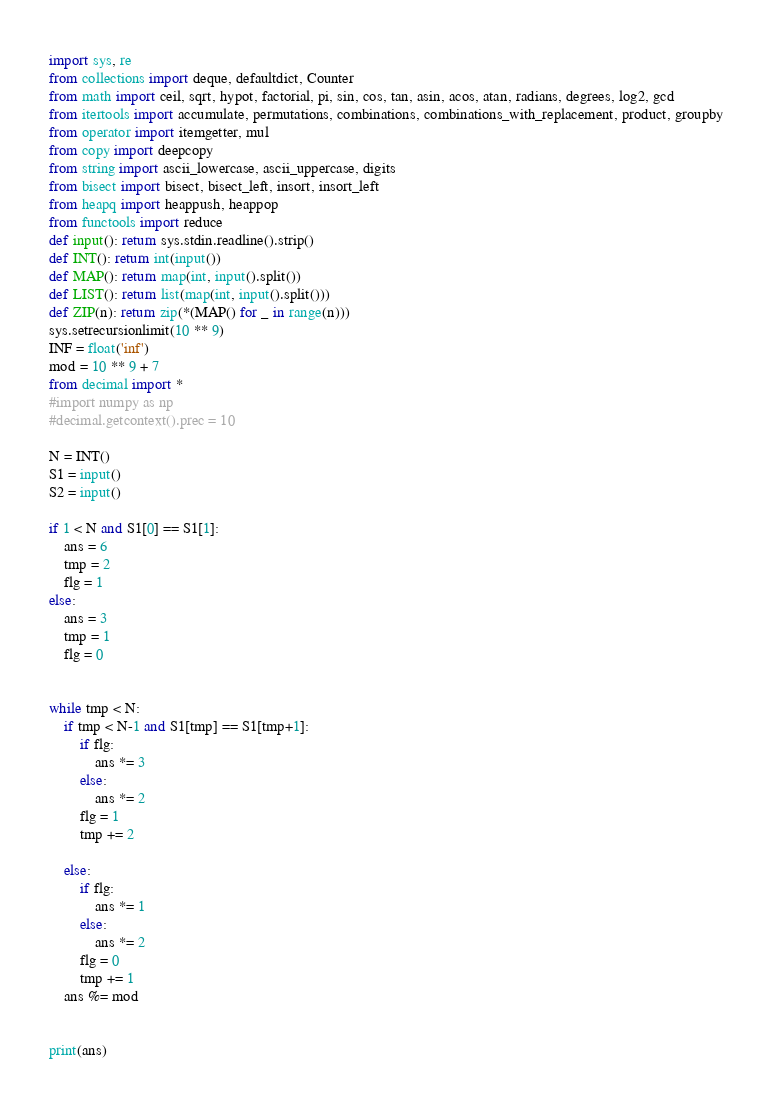<code> <loc_0><loc_0><loc_500><loc_500><_Python_>import sys, re
from collections import deque, defaultdict, Counter
from math import ceil, sqrt, hypot, factorial, pi, sin, cos, tan, asin, acos, atan, radians, degrees, log2, gcd
from itertools import accumulate, permutations, combinations, combinations_with_replacement, product, groupby
from operator import itemgetter, mul
from copy import deepcopy
from string import ascii_lowercase, ascii_uppercase, digits
from bisect import bisect, bisect_left, insort, insort_left
from heapq import heappush, heappop
from functools import reduce
def input(): return sys.stdin.readline().strip()
def INT(): return int(input())
def MAP(): return map(int, input().split())
def LIST(): return list(map(int, input().split()))
def ZIP(n): return zip(*(MAP() for _ in range(n)))
sys.setrecursionlimit(10 ** 9)
INF = float('inf')
mod = 10 ** 9 + 7
from decimal import *
#import numpy as np
#decimal.getcontext().prec = 10

N = INT()
S1 = input()
S2 = input()

if 1 < N and S1[0] == S1[1]:
	ans = 6
	tmp = 2
	flg = 1
else:
	ans = 3
	tmp = 1
	flg = 0


while tmp < N:
	if tmp < N-1 and S1[tmp] == S1[tmp+1]:
		if flg:
			ans *= 3
		else:
			ans *= 2
		flg = 1
		tmp += 2

	else:
		if flg:
			ans *= 1
		else:
			ans *= 2
		flg = 0
		tmp += 1
	ans %= mod


print(ans)


</code> 